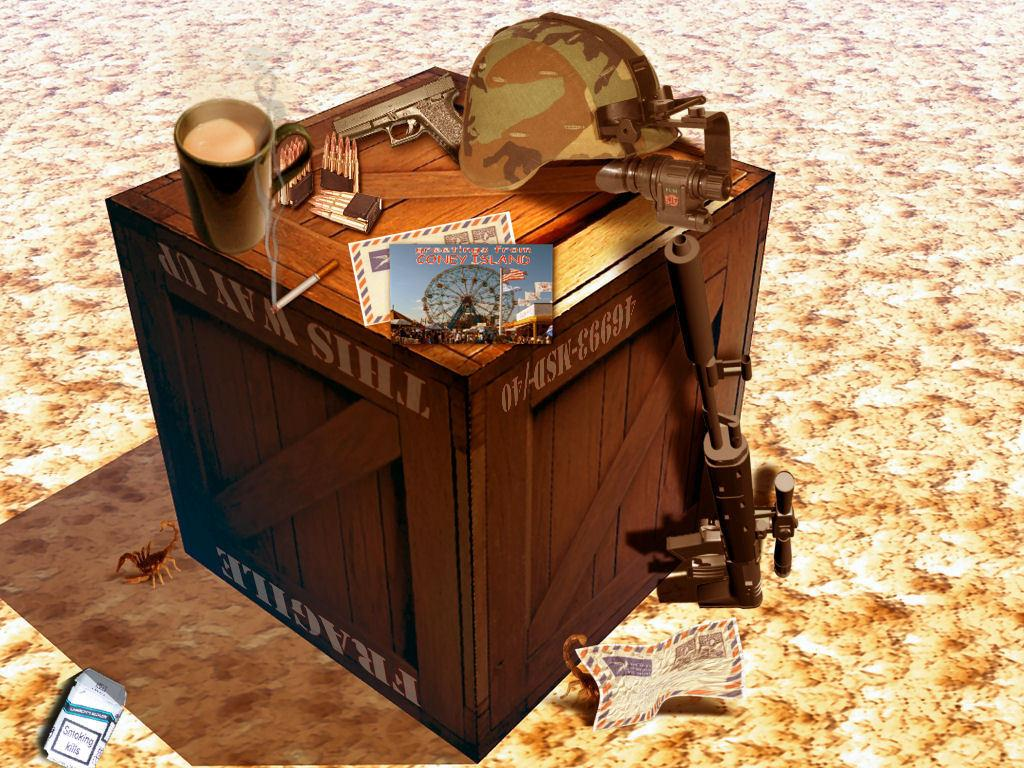What object is present in the painting that is typically used for containing items? The painting contains a box. What type of headwear is depicted in the painting? There is a cap in the painting. What weapon is featured in the painting? There is a gun in the painting. How many caps are present in the painting? There are caps in the painting. What type of writing material is shown in the painting? There are papers in the painting. What object is used for unlocking or securing in the painting? There is a key in the painting. What type of animal is featured in the painting? The painting features Scorpios. Where is a paper located in the painting? There is a paper on a path in the painting. What type of jellyfish can be seen swimming in the painting? There are no jellyfish present in the painting; it features a box, cap, gun, caps, papers, key, Scorpios, and a paper on a path. 